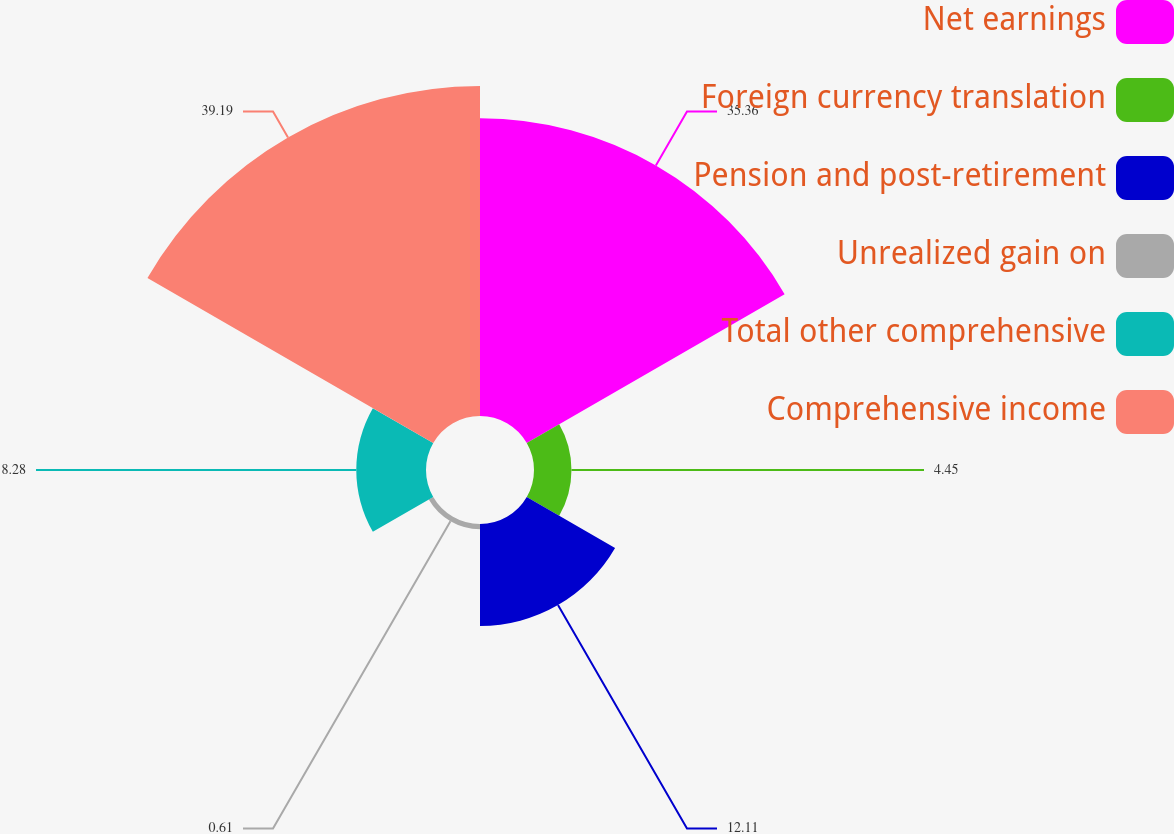Convert chart. <chart><loc_0><loc_0><loc_500><loc_500><pie_chart><fcel>Net earnings<fcel>Foreign currency translation<fcel>Pension and post-retirement<fcel>Unrealized gain on<fcel>Total other comprehensive<fcel>Comprehensive income<nl><fcel>35.36%<fcel>4.45%<fcel>12.11%<fcel>0.61%<fcel>8.28%<fcel>39.19%<nl></chart> 